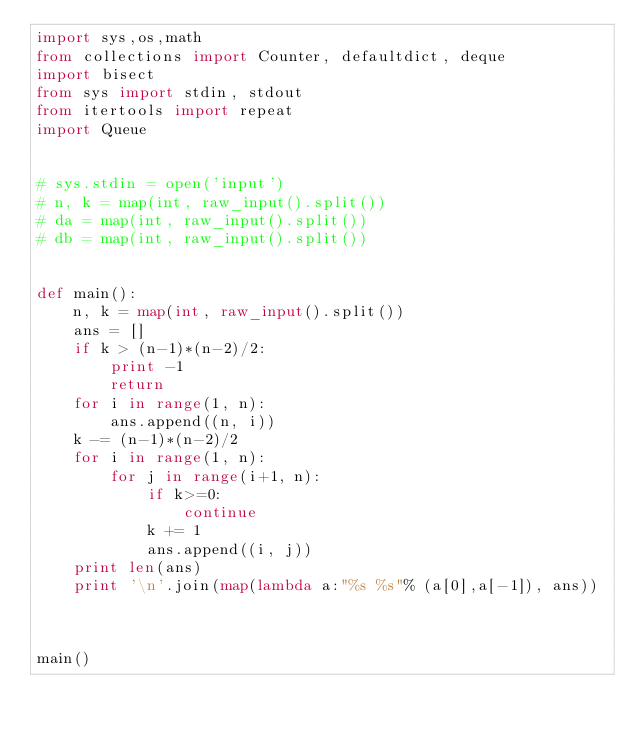Convert code to text. <code><loc_0><loc_0><loc_500><loc_500><_Python_>import sys,os,math
from collections import Counter, defaultdict, deque
import bisect
from sys import stdin, stdout
from itertools import repeat
import Queue


# sys.stdin = open('input')
# n, k = map(int, raw_input().split())
# da = map(int, raw_input().split())
# db = map(int, raw_input().split())


def main():
    n, k = map(int, raw_input().split())
    ans = []
    if k > (n-1)*(n-2)/2:
        print -1
        return
    for i in range(1, n):
        ans.append((n, i))
    k -= (n-1)*(n-2)/2
    for i in range(1, n):
        for j in range(i+1, n):
            if k>=0:
                continue
            k += 1
            ans.append((i, j))
    print len(ans)
    print '\n'.join(map(lambda a:"%s %s"% (a[0],a[-1]), ans))
        


main()
</code> 